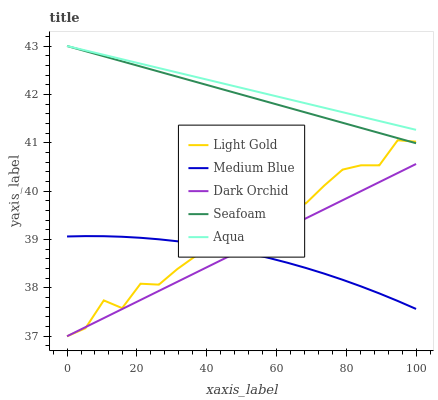Does Medium Blue have the minimum area under the curve?
Answer yes or no. Yes. Does Aqua have the maximum area under the curve?
Answer yes or no. Yes. Does Light Gold have the minimum area under the curve?
Answer yes or no. No. Does Light Gold have the maximum area under the curve?
Answer yes or no. No. Is Dark Orchid the smoothest?
Answer yes or no. Yes. Is Light Gold the roughest?
Answer yes or no. Yes. Is Medium Blue the smoothest?
Answer yes or no. No. Is Medium Blue the roughest?
Answer yes or no. No. Does Medium Blue have the lowest value?
Answer yes or no. No. Does Light Gold have the highest value?
Answer yes or no. No. Is Medium Blue less than Seafoam?
Answer yes or no. Yes. Is Seafoam greater than Medium Blue?
Answer yes or no. Yes. Does Medium Blue intersect Seafoam?
Answer yes or no. No. 